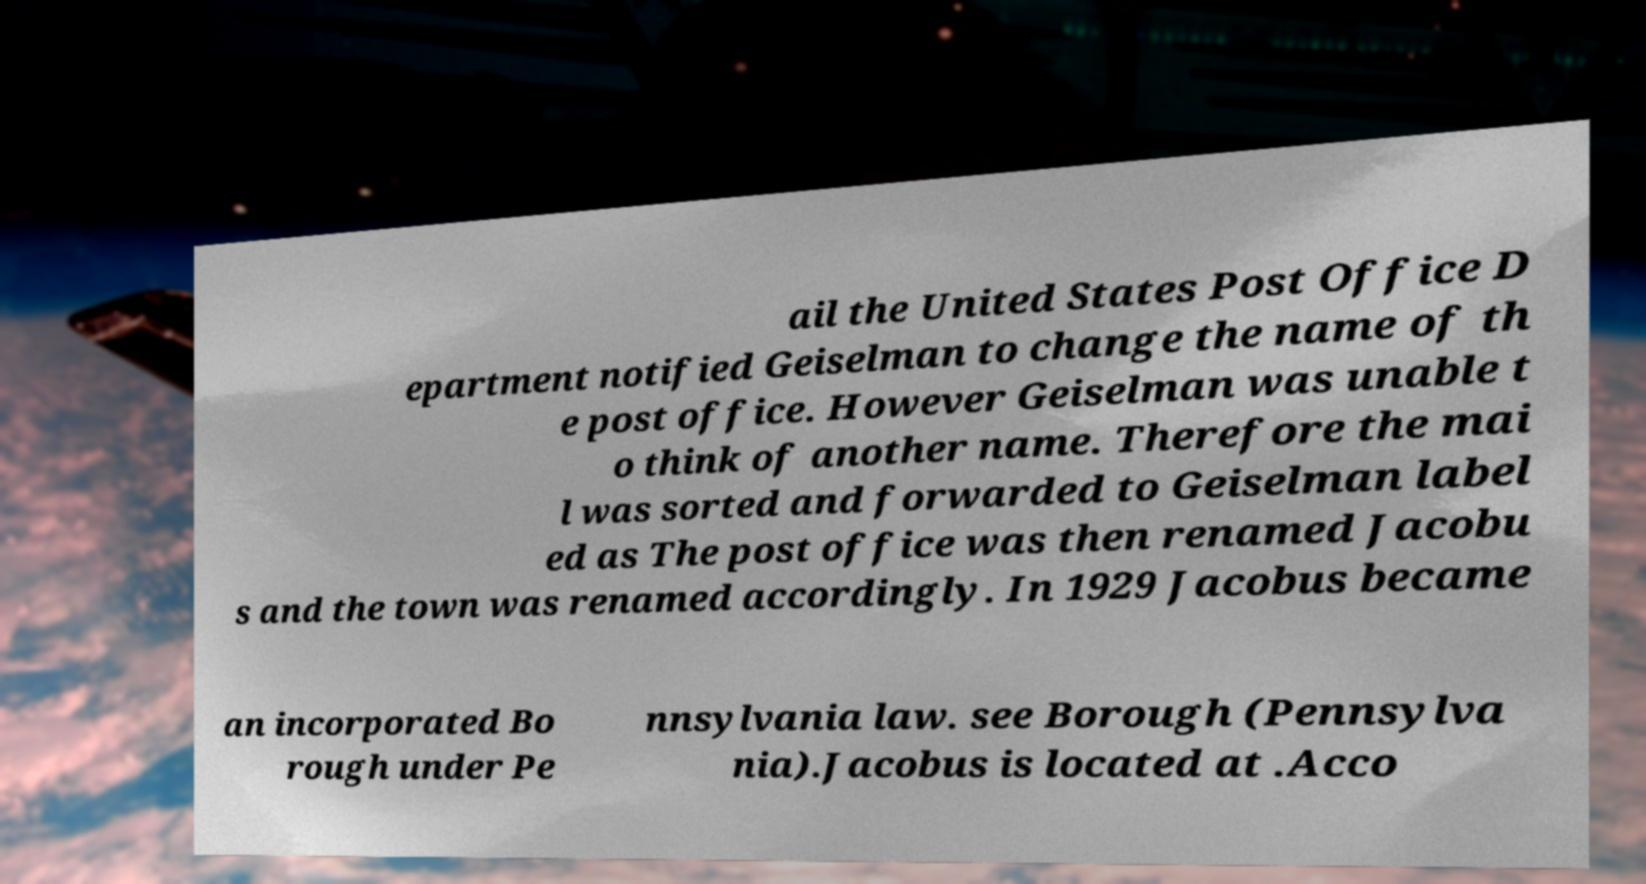Please identify and transcribe the text found in this image. ail the United States Post Office D epartment notified Geiselman to change the name of th e post office. However Geiselman was unable t o think of another name. Therefore the mai l was sorted and forwarded to Geiselman label ed as The post office was then renamed Jacobu s and the town was renamed accordingly. In 1929 Jacobus became an incorporated Bo rough under Pe nnsylvania law. see Borough (Pennsylva nia).Jacobus is located at .Acco 